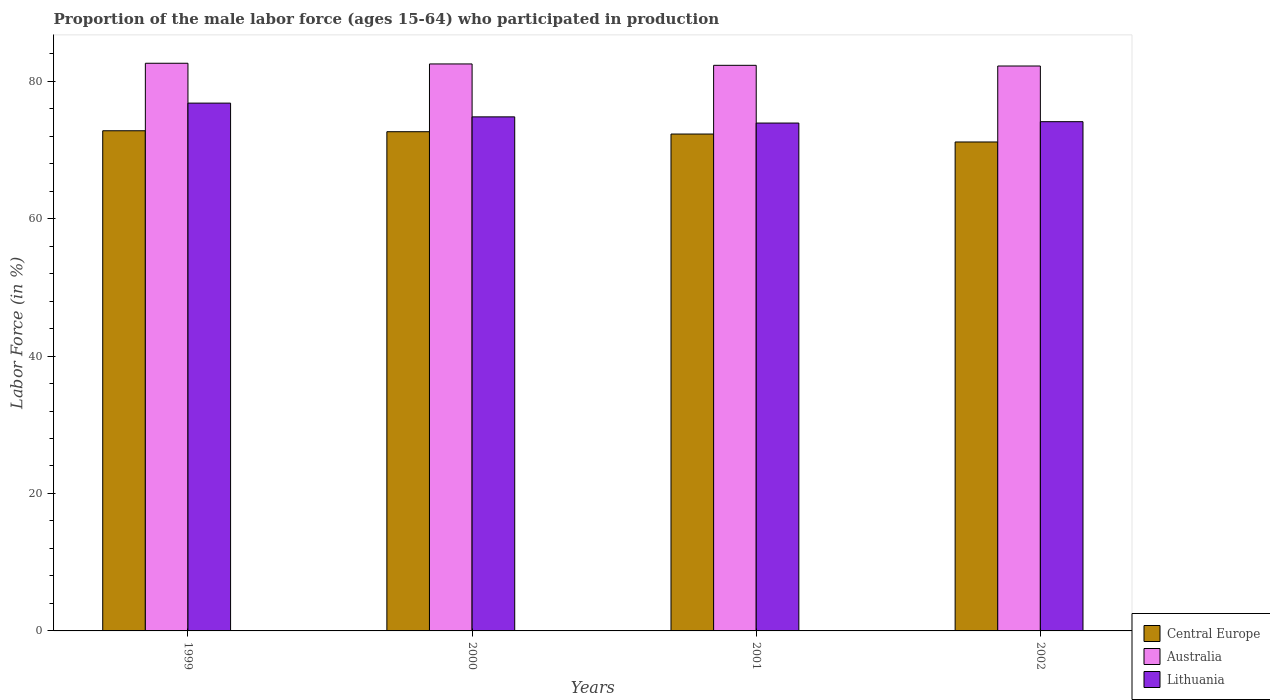How many different coloured bars are there?
Give a very brief answer. 3. How many groups of bars are there?
Offer a very short reply. 4. Are the number of bars per tick equal to the number of legend labels?
Give a very brief answer. Yes. Are the number of bars on each tick of the X-axis equal?
Provide a succinct answer. Yes. In how many cases, is the number of bars for a given year not equal to the number of legend labels?
Keep it short and to the point. 0. What is the proportion of the male labor force who participated in production in Lithuania in 2000?
Offer a terse response. 74.8. Across all years, what is the maximum proportion of the male labor force who participated in production in Central Europe?
Your answer should be compact. 72.78. Across all years, what is the minimum proportion of the male labor force who participated in production in Central Europe?
Your answer should be compact. 71.15. What is the total proportion of the male labor force who participated in production in Lithuania in the graph?
Make the answer very short. 299.6. What is the difference between the proportion of the male labor force who participated in production in Lithuania in 2001 and the proportion of the male labor force who participated in production in Central Europe in 1999?
Provide a succinct answer. 1.12. What is the average proportion of the male labor force who participated in production in Australia per year?
Keep it short and to the point. 82.4. In the year 2002, what is the difference between the proportion of the male labor force who participated in production in Central Europe and proportion of the male labor force who participated in production in Australia?
Make the answer very short. -11.05. In how many years, is the proportion of the male labor force who participated in production in Lithuania greater than 80 %?
Your response must be concise. 0. What is the ratio of the proportion of the male labor force who participated in production in Central Europe in 1999 to that in 2002?
Make the answer very short. 1.02. Is the proportion of the male labor force who participated in production in Lithuania in 2001 less than that in 2002?
Keep it short and to the point. Yes. Is the difference between the proportion of the male labor force who participated in production in Central Europe in 1999 and 2002 greater than the difference between the proportion of the male labor force who participated in production in Australia in 1999 and 2002?
Give a very brief answer. Yes. What is the difference between the highest and the second highest proportion of the male labor force who participated in production in Australia?
Make the answer very short. 0.1. What is the difference between the highest and the lowest proportion of the male labor force who participated in production in Lithuania?
Offer a very short reply. 2.9. Is the sum of the proportion of the male labor force who participated in production in Central Europe in 2000 and 2002 greater than the maximum proportion of the male labor force who participated in production in Australia across all years?
Offer a terse response. Yes. What does the 1st bar from the left in 2001 represents?
Keep it short and to the point. Central Europe. What does the 2nd bar from the right in 1999 represents?
Provide a short and direct response. Australia. How many bars are there?
Provide a short and direct response. 12. Are all the bars in the graph horizontal?
Make the answer very short. No. How are the legend labels stacked?
Keep it short and to the point. Vertical. What is the title of the graph?
Make the answer very short. Proportion of the male labor force (ages 15-64) who participated in production. Does "Mauritius" appear as one of the legend labels in the graph?
Ensure brevity in your answer.  No. What is the label or title of the X-axis?
Offer a terse response. Years. What is the Labor Force (in %) in Central Europe in 1999?
Your answer should be very brief. 72.78. What is the Labor Force (in %) in Australia in 1999?
Keep it short and to the point. 82.6. What is the Labor Force (in %) in Lithuania in 1999?
Provide a succinct answer. 76.8. What is the Labor Force (in %) of Central Europe in 2000?
Your response must be concise. 72.64. What is the Labor Force (in %) of Australia in 2000?
Your response must be concise. 82.5. What is the Labor Force (in %) of Lithuania in 2000?
Your answer should be compact. 74.8. What is the Labor Force (in %) in Central Europe in 2001?
Keep it short and to the point. 72.3. What is the Labor Force (in %) of Australia in 2001?
Make the answer very short. 82.3. What is the Labor Force (in %) of Lithuania in 2001?
Your response must be concise. 73.9. What is the Labor Force (in %) in Central Europe in 2002?
Offer a very short reply. 71.15. What is the Labor Force (in %) of Australia in 2002?
Offer a terse response. 82.2. What is the Labor Force (in %) of Lithuania in 2002?
Offer a very short reply. 74.1. Across all years, what is the maximum Labor Force (in %) of Central Europe?
Your answer should be compact. 72.78. Across all years, what is the maximum Labor Force (in %) in Australia?
Your answer should be very brief. 82.6. Across all years, what is the maximum Labor Force (in %) of Lithuania?
Give a very brief answer. 76.8. Across all years, what is the minimum Labor Force (in %) in Central Europe?
Give a very brief answer. 71.15. Across all years, what is the minimum Labor Force (in %) in Australia?
Offer a terse response. 82.2. Across all years, what is the minimum Labor Force (in %) of Lithuania?
Make the answer very short. 73.9. What is the total Labor Force (in %) of Central Europe in the graph?
Provide a short and direct response. 288.86. What is the total Labor Force (in %) of Australia in the graph?
Provide a short and direct response. 329.6. What is the total Labor Force (in %) of Lithuania in the graph?
Offer a terse response. 299.6. What is the difference between the Labor Force (in %) in Central Europe in 1999 and that in 2000?
Your answer should be very brief. 0.14. What is the difference between the Labor Force (in %) in Central Europe in 1999 and that in 2001?
Provide a succinct answer. 0.48. What is the difference between the Labor Force (in %) of Australia in 1999 and that in 2001?
Ensure brevity in your answer.  0.3. What is the difference between the Labor Force (in %) of Lithuania in 1999 and that in 2001?
Your answer should be very brief. 2.9. What is the difference between the Labor Force (in %) of Central Europe in 1999 and that in 2002?
Provide a succinct answer. 1.63. What is the difference between the Labor Force (in %) in Central Europe in 2000 and that in 2001?
Offer a very short reply. 0.34. What is the difference between the Labor Force (in %) of Australia in 2000 and that in 2001?
Keep it short and to the point. 0.2. What is the difference between the Labor Force (in %) in Central Europe in 2000 and that in 2002?
Offer a terse response. 1.49. What is the difference between the Labor Force (in %) of Australia in 2000 and that in 2002?
Keep it short and to the point. 0.3. What is the difference between the Labor Force (in %) in Central Europe in 2001 and that in 2002?
Ensure brevity in your answer.  1.16. What is the difference between the Labor Force (in %) of Central Europe in 1999 and the Labor Force (in %) of Australia in 2000?
Give a very brief answer. -9.72. What is the difference between the Labor Force (in %) of Central Europe in 1999 and the Labor Force (in %) of Lithuania in 2000?
Ensure brevity in your answer.  -2.02. What is the difference between the Labor Force (in %) of Central Europe in 1999 and the Labor Force (in %) of Australia in 2001?
Your answer should be very brief. -9.52. What is the difference between the Labor Force (in %) in Central Europe in 1999 and the Labor Force (in %) in Lithuania in 2001?
Provide a short and direct response. -1.12. What is the difference between the Labor Force (in %) in Central Europe in 1999 and the Labor Force (in %) in Australia in 2002?
Your answer should be compact. -9.42. What is the difference between the Labor Force (in %) of Central Europe in 1999 and the Labor Force (in %) of Lithuania in 2002?
Provide a succinct answer. -1.32. What is the difference between the Labor Force (in %) of Australia in 1999 and the Labor Force (in %) of Lithuania in 2002?
Give a very brief answer. 8.5. What is the difference between the Labor Force (in %) in Central Europe in 2000 and the Labor Force (in %) in Australia in 2001?
Provide a succinct answer. -9.66. What is the difference between the Labor Force (in %) in Central Europe in 2000 and the Labor Force (in %) in Lithuania in 2001?
Your answer should be very brief. -1.26. What is the difference between the Labor Force (in %) of Australia in 2000 and the Labor Force (in %) of Lithuania in 2001?
Provide a short and direct response. 8.6. What is the difference between the Labor Force (in %) of Central Europe in 2000 and the Labor Force (in %) of Australia in 2002?
Make the answer very short. -9.56. What is the difference between the Labor Force (in %) of Central Europe in 2000 and the Labor Force (in %) of Lithuania in 2002?
Ensure brevity in your answer.  -1.46. What is the difference between the Labor Force (in %) in Central Europe in 2001 and the Labor Force (in %) in Australia in 2002?
Your answer should be very brief. -9.9. What is the difference between the Labor Force (in %) in Central Europe in 2001 and the Labor Force (in %) in Lithuania in 2002?
Ensure brevity in your answer.  -1.8. What is the difference between the Labor Force (in %) in Australia in 2001 and the Labor Force (in %) in Lithuania in 2002?
Your answer should be compact. 8.2. What is the average Labor Force (in %) in Central Europe per year?
Ensure brevity in your answer.  72.22. What is the average Labor Force (in %) in Australia per year?
Make the answer very short. 82.4. What is the average Labor Force (in %) of Lithuania per year?
Offer a terse response. 74.9. In the year 1999, what is the difference between the Labor Force (in %) in Central Europe and Labor Force (in %) in Australia?
Make the answer very short. -9.82. In the year 1999, what is the difference between the Labor Force (in %) of Central Europe and Labor Force (in %) of Lithuania?
Make the answer very short. -4.02. In the year 1999, what is the difference between the Labor Force (in %) in Australia and Labor Force (in %) in Lithuania?
Your answer should be very brief. 5.8. In the year 2000, what is the difference between the Labor Force (in %) of Central Europe and Labor Force (in %) of Australia?
Make the answer very short. -9.86. In the year 2000, what is the difference between the Labor Force (in %) in Central Europe and Labor Force (in %) in Lithuania?
Keep it short and to the point. -2.16. In the year 2001, what is the difference between the Labor Force (in %) of Central Europe and Labor Force (in %) of Australia?
Offer a very short reply. -10. In the year 2001, what is the difference between the Labor Force (in %) of Central Europe and Labor Force (in %) of Lithuania?
Offer a terse response. -1.6. In the year 2002, what is the difference between the Labor Force (in %) in Central Europe and Labor Force (in %) in Australia?
Give a very brief answer. -11.05. In the year 2002, what is the difference between the Labor Force (in %) of Central Europe and Labor Force (in %) of Lithuania?
Give a very brief answer. -2.95. What is the ratio of the Labor Force (in %) of Australia in 1999 to that in 2000?
Offer a very short reply. 1. What is the ratio of the Labor Force (in %) of Lithuania in 1999 to that in 2000?
Offer a very short reply. 1.03. What is the ratio of the Labor Force (in %) in Central Europe in 1999 to that in 2001?
Offer a very short reply. 1.01. What is the ratio of the Labor Force (in %) of Australia in 1999 to that in 2001?
Your answer should be very brief. 1. What is the ratio of the Labor Force (in %) of Lithuania in 1999 to that in 2001?
Your answer should be very brief. 1.04. What is the ratio of the Labor Force (in %) in Central Europe in 1999 to that in 2002?
Keep it short and to the point. 1.02. What is the ratio of the Labor Force (in %) in Australia in 1999 to that in 2002?
Your answer should be very brief. 1. What is the ratio of the Labor Force (in %) of Lithuania in 1999 to that in 2002?
Offer a very short reply. 1.04. What is the ratio of the Labor Force (in %) of Australia in 2000 to that in 2001?
Offer a very short reply. 1. What is the ratio of the Labor Force (in %) in Lithuania in 2000 to that in 2001?
Make the answer very short. 1.01. What is the ratio of the Labor Force (in %) of Lithuania in 2000 to that in 2002?
Your answer should be very brief. 1.01. What is the ratio of the Labor Force (in %) in Central Europe in 2001 to that in 2002?
Provide a short and direct response. 1.02. What is the ratio of the Labor Force (in %) of Australia in 2001 to that in 2002?
Provide a succinct answer. 1. What is the ratio of the Labor Force (in %) in Lithuania in 2001 to that in 2002?
Provide a succinct answer. 1. What is the difference between the highest and the second highest Labor Force (in %) in Central Europe?
Give a very brief answer. 0.14. What is the difference between the highest and the second highest Labor Force (in %) in Australia?
Your answer should be very brief. 0.1. What is the difference between the highest and the lowest Labor Force (in %) in Central Europe?
Give a very brief answer. 1.63. What is the difference between the highest and the lowest Labor Force (in %) of Lithuania?
Give a very brief answer. 2.9. 